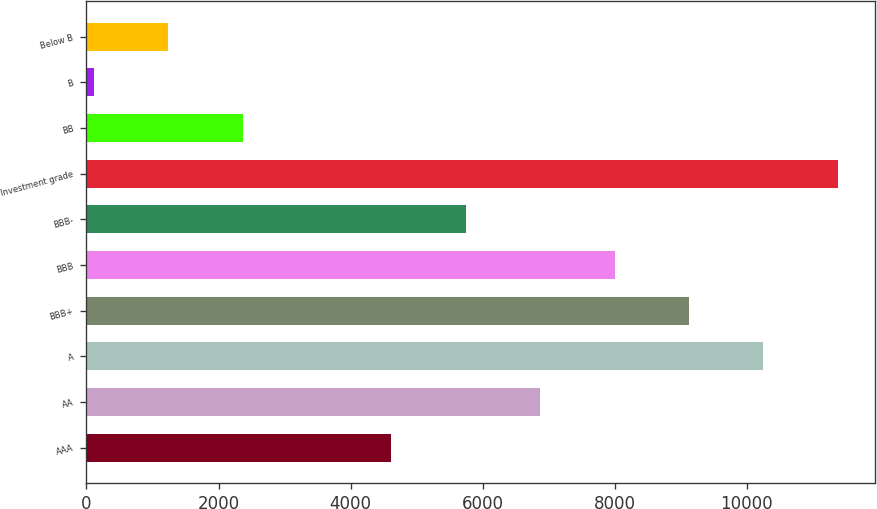Convert chart to OTSL. <chart><loc_0><loc_0><loc_500><loc_500><bar_chart><fcel>AAA<fcel>AA<fcel>A<fcel>BBB+<fcel>BBB<fcel>BBB-<fcel>Investment grade<fcel>BB<fcel>B<fcel>Below B<nl><fcel>4617.8<fcel>6871.2<fcel>10251.3<fcel>9124.6<fcel>7997.9<fcel>5744.5<fcel>11378<fcel>2364.4<fcel>111<fcel>1237.7<nl></chart> 